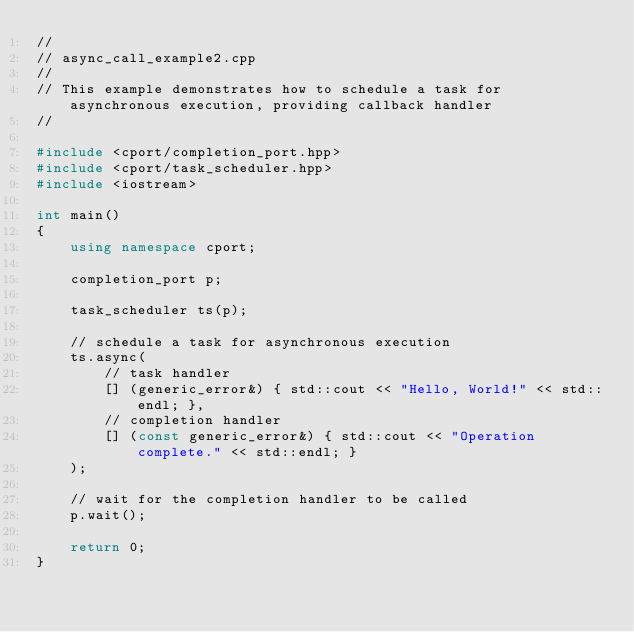Convert code to text. <code><loc_0><loc_0><loc_500><loc_500><_C++_>//
// async_call_example2.cpp
//
// This example demonstrates how to schedule a task for asynchronous execution, providing callback handler
//

#include <cport/completion_port.hpp>
#include <cport/task_scheduler.hpp>
#include <iostream>

int main()
{
    using namespace cport;

    completion_port p;

    task_scheduler ts(p);

    // schedule a task for asynchronous execution
    ts.async(
        // task handler
        [] (generic_error&) { std::cout << "Hello, World!" << std::endl; },
        // completion handler
        [] (const generic_error&) { std::cout << "Operation complete." << std::endl; }
    );

    // wait for the completion handler to be called
    p.wait();

    return 0;
}</code> 